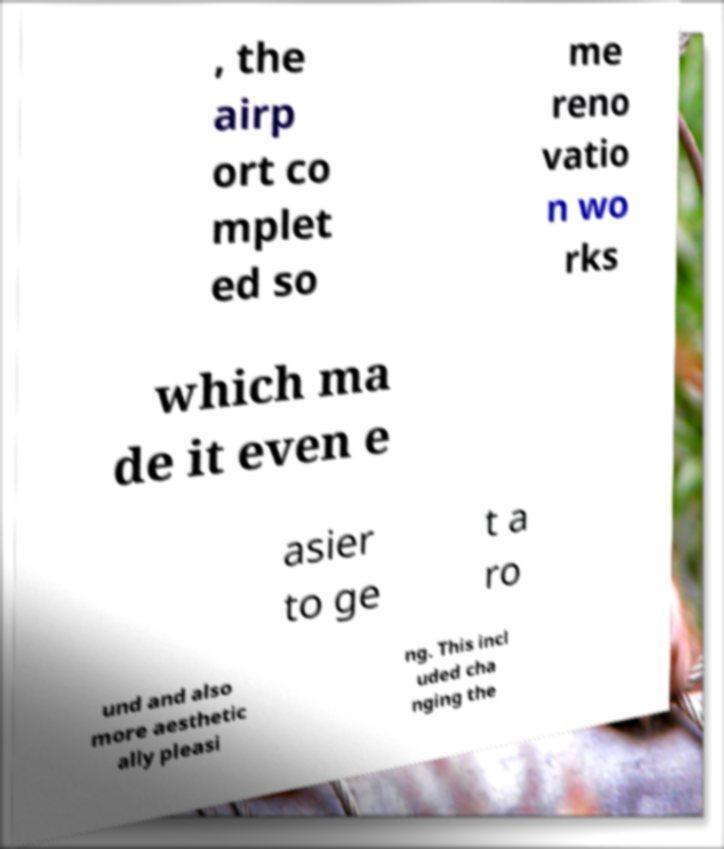Please identify and transcribe the text found in this image. , the airp ort co mplet ed so me reno vatio n wo rks which ma de it even e asier to ge t a ro und and also more aesthetic ally pleasi ng. This incl uded cha nging the 